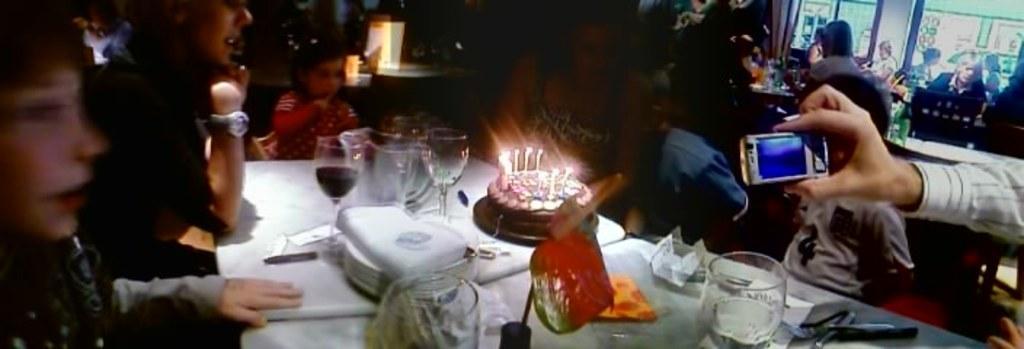In one or two sentences, can you explain what this image depicts? In this image, we can see a table, on that table there are some glasses and we can see a cake, there are some candles on the cake, we can see some people sitting on the chairs around the table. 